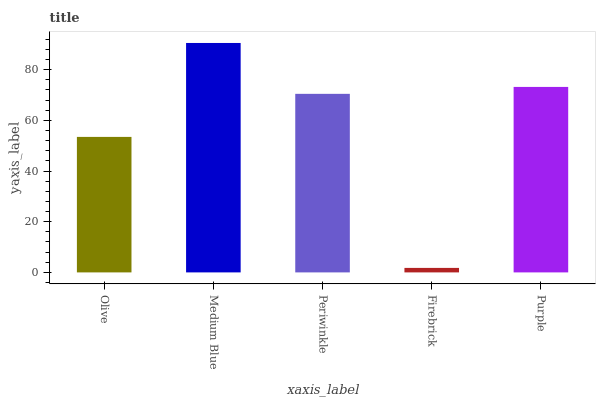Is Firebrick the minimum?
Answer yes or no. Yes. Is Medium Blue the maximum?
Answer yes or no. Yes. Is Periwinkle the minimum?
Answer yes or no. No. Is Periwinkle the maximum?
Answer yes or no. No. Is Medium Blue greater than Periwinkle?
Answer yes or no. Yes. Is Periwinkle less than Medium Blue?
Answer yes or no. Yes. Is Periwinkle greater than Medium Blue?
Answer yes or no. No. Is Medium Blue less than Periwinkle?
Answer yes or no. No. Is Periwinkle the high median?
Answer yes or no. Yes. Is Periwinkle the low median?
Answer yes or no. Yes. Is Purple the high median?
Answer yes or no. No. Is Firebrick the low median?
Answer yes or no. No. 